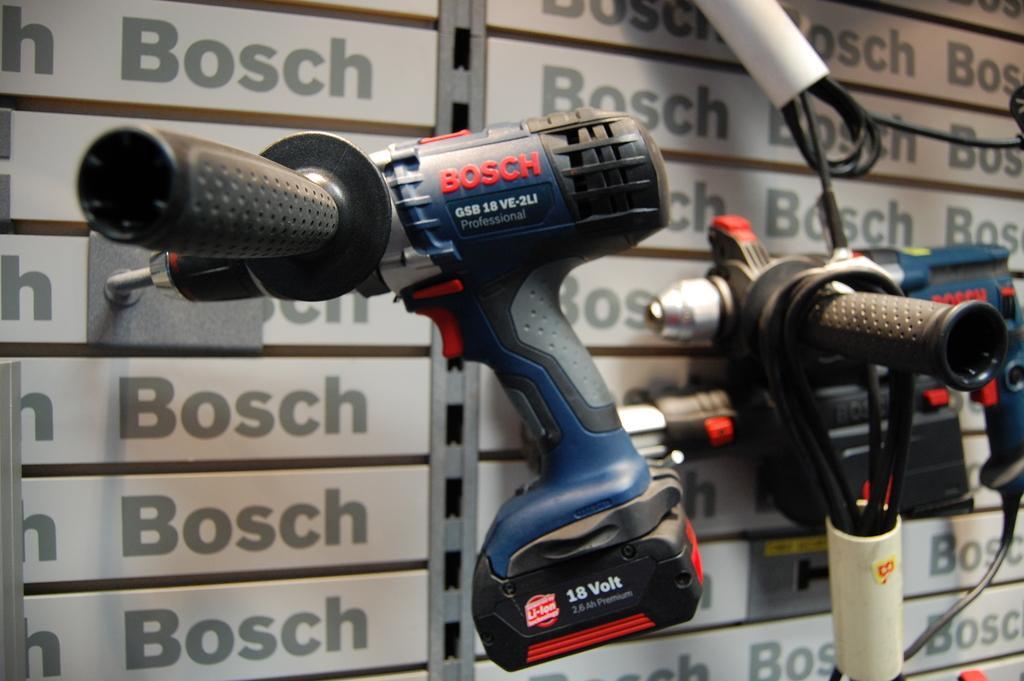How would you summarize this image in a sentence or two? In this image I can see few blue colour equipment, wires and in the background I can see something is written at many places. 